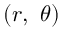<formula> <loc_0><loc_0><loc_500><loc_500>( r , \ \theta )</formula> 